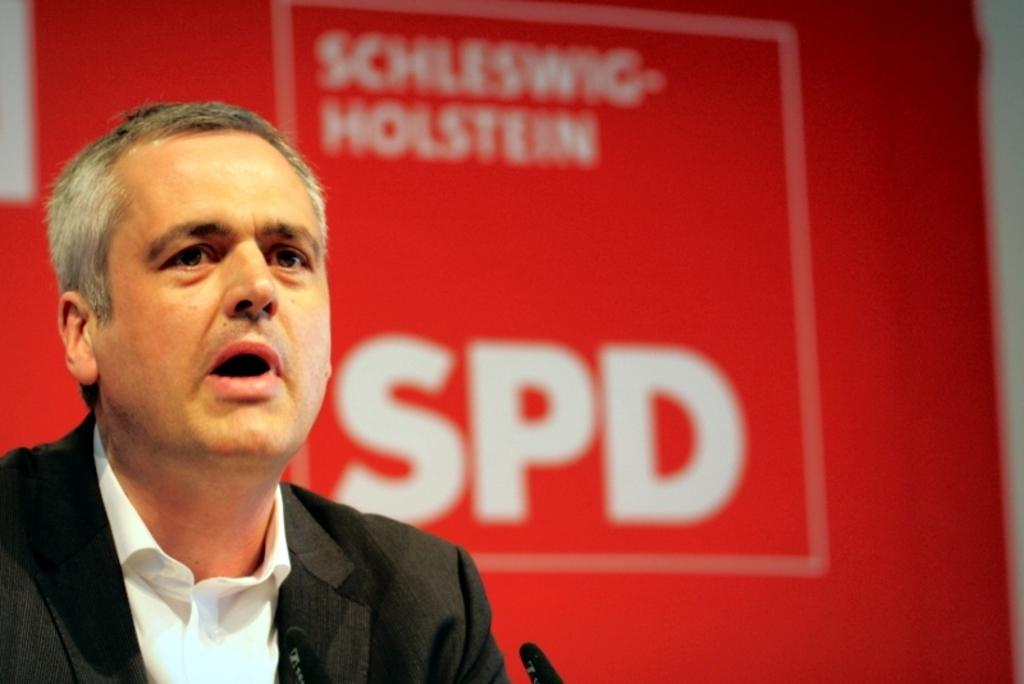Who is present in the image? There is a person in the image. Where is the person located in the image? The person is on the left side of the image. What is the person wearing? The person is wearing a black coat. What is the person doing in the image? The person is talking. What else can be seen in the image besides the person? There is a banner in the image. What type of tin is being used to advertise a force in the image? There is no tin, advertisement, or force present in the image. 